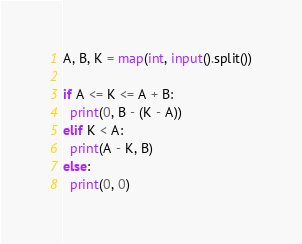<code> <loc_0><loc_0><loc_500><loc_500><_Python_>A, B, K = map(int, input().split())

if A <= K <= A + B:
  print(0, B - (K - A))
elif K < A:
  print(A - K, B)
else:
  print(0, 0)</code> 